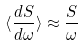<formula> <loc_0><loc_0><loc_500><loc_500>\langle \frac { d S } { d \omega } \rangle \approx \frac { S } { \omega }</formula> 